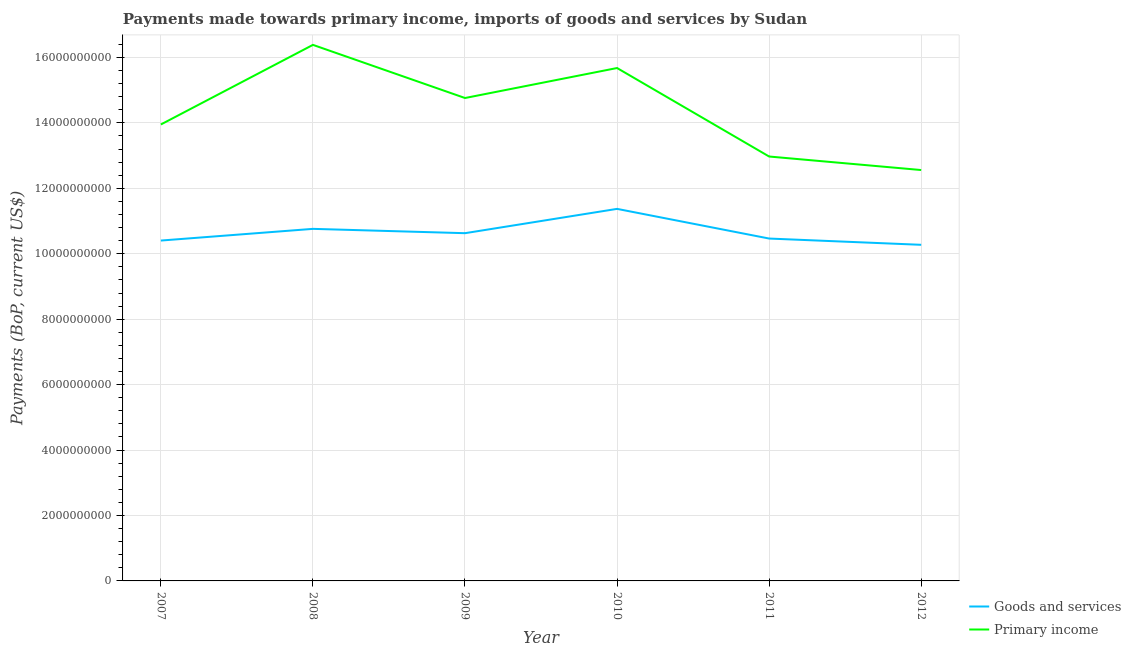How many different coloured lines are there?
Offer a very short reply. 2. Is the number of lines equal to the number of legend labels?
Offer a terse response. Yes. What is the payments made towards goods and services in 2011?
Make the answer very short. 1.05e+1. Across all years, what is the maximum payments made towards primary income?
Make the answer very short. 1.64e+1. Across all years, what is the minimum payments made towards goods and services?
Your response must be concise. 1.03e+1. In which year was the payments made towards primary income minimum?
Your answer should be compact. 2012. What is the total payments made towards primary income in the graph?
Make the answer very short. 8.63e+1. What is the difference between the payments made towards goods and services in 2009 and that in 2012?
Provide a short and direct response. 3.55e+08. What is the difference between the payments made towards primary income in 2011 and the payments made towards goods and services in 2010?
Your answer should be very brief. 1.60e+09. What is the average payments made towards primary income per year?
Your response must be concise. 1.44e+1. In the year 2012, what is the difference between the payments made towards primary income and payments made towards goods and services?
Ensure brevity in your answer.  2.29e+09. What is the ratio of the payments made towards primary income in 2008 to that in 2011?
Offer a very short reply. 1.26. Is the payments made towards primary income in 2007 less than that in 2011?
Make the answer very short. No. Is the difference between the payments made towards primary income in 2011 and 2012 greater than the difference between the payments made towards goods and services in 2011 and 2012?
Offer a terse response. Yes. What is the difference between the highest and the second highest payments made towards goods and services?
Ensure brevity in your answer.  6.11e+08. What is the difference between the highest and the lowest payments made towards goods and services?
Keep it short and to the point. 1.10e+09. In how many years, is the payments made towards goods and services greater than the average payments made towards goods and services taken over all years?
Provide a succinct answer. 2. Does the payments made towards goods and services monotonically increase over the years?
Keep it short and to the point. No. Is the payments made towards goods and services strictly greater than the payments made towards primary income over the years?
Your response must be concise. No. Is the payments made towards primary income strictly less than the payments made towards goods and services over the years?
Offer a very short reply. No. How many years are there in the graph?
Provide a short and direct response. 6. Are the values on the major ticks of Y-axis written in scientific E-notation?
Your response must be concise. No. How many legend labels are there?
Provide a short and direct response. 2. How are the legend labels stacked?
Keep it short and to the point. Vertical. What is the title of the graph?
Keep it short and to the point. Payments made towards primary income, imports of goods and services by Sudan. What is the label or title of the X-axis?
Your response must be concise. Year. What is the label or title of the Y-axis?
Offer a terse response. Payments (BoP, current US$). What is the Payments (BoP, current US$) of Goods and services in 2007?
Your answer should be compact. 1.04e+1. What is the Payments (BoP, current US$) in Primary income in 2007?
Your response must be concise. 1.40e+1. What is the Payments (BoP, current US$) in Goods and services in 2008?
Offer a terse response. 1.08e+1. What is the Payments (BoP, current US$) of Primary income in 2008?
Your answer should be very brief. 1.64e+1. What is the Payments (BoP, current US$) of Goods and services in 2009?
Your answer should be compact. 1.06e+1. What is the Payments (BoP, current US$) in Primary income in 2009?
Your response must be concise. 1.48e+1. What is the Payments (BoP, current US$) of Goods and services in 2010?
Provide a succinct answer. 1.14e+1. What is the Payments (BoP, current US$) of Primary income in 2010?
Make the answer very short. 1.57e+1. What is the Payments (BoP, current US$) in Goods and services in 2011?
Ensure brevity in your answer.  1.05e+1. What is the Payments (BoP, current US$) of Primary income in 2011?
Your response must be concise. 1.30e+1. What is the Payments (BoP, current US$) in Goods and services in 2012?
Offer a terse response. 1.03e+1. What is the Payments (BoP, current US$) in Primary income in 2012?
Offer a terse response. 1.26e+1. Across all years, what is the maximum Payments (BoP, current US$) in Goods and services?
Your response must be concise. 1.14e+1. Across all years, what is the maximum Payments (BoP, current US$) in Primary income?
Offer a terse response. 1.64e+1. Across all years, what is the minimum Payments (BoP, current US$) in Goods and services?
Your answer should be very brief. 1.03e+1. Across all years, what is the minimum Payments (BoP, current US$) in Primary income?
Your answer should be compact. 1.26e+1. What is the total Payments (BoP, current US$) in Goods and services in the graph?
Offer a very short reply. 6.39e+1. What is the total Payments (BoP, current US$) in Primary income in the graph?
Make the answer very short. 8.63e+1. What is the difference between the Payments (BoP, current US$) in Goods and services in 2007 and that in 2008?
Your answer should be very brief. -3.58e+08. What is the difference between the Payments (BoP, current US$) of Primary income in 2007 and that in 2008?
Make the answer very short. -2.43e+09. What is the difference between the Payments (BoP, current US$) of Goods and services in 2007 and that in 2009?
Keep it short and to the point. -2.25e+08. What is the difference between the Payments (BoP, current US$) of Primary income in 2007 and that in 2009?
Ensure brevity in your answer.  -8.09e+08. What is the difference between the Payments (BoP, current US$) of Goods and services in 2007 and that in 2010?
Give a very brief answer. -9.68e+08. What is the difference between the Payments (BoP, current US$) of Primary income in 2007 and that in 2010?
Ensure brevity in your answer.  -1.73e+09. What is the difference between the Payments (BoP, current US$) in Goods and services in 2007 and that in 2011?
Your answer should be very brief. -6.16e+07. What is the difference between the Payments (BoP, current US$) of Primary income in 2007 and that in 2011?
Make the answer very short. 9.79e+08. What is the difference between the Payments (BoP, current US$) of Goods and services in 2007 and that in 2012?
Make the answer very short. 1.30e+08. What is the difference between the Payments (BoP, current US$) in Primary income in 2007 and that in 2012?
Give a very brief answer. 1.39e+09. What is the difference between the Payments (BoP, current US$) in Goods and services in 2008 and that in 2009?
Give a very brief answer. 1.32e+08. What is the difference between the Payments (BoP, current US$) in Primary income in 2008 and that in 2009?
Give a very brief answer. 1.62e+09. What is the difference between the Payments (BoP, current US$) in Goods and services in 2008 and that in 2010?
Provide a succinct answer. -6.11e+08. What is the difference between the Payments (BoP, current US$) in Primary income in 2008 and that in 2010?
Your answer should be very brief. 7.08e+08. What is the difference between the Payments (BoP, current US$) in Goods and services in 2008 and that in 2011?
Your response must be concise. 2.96e+08. What is the difference between the Payments (BoP, current US$) of Primary income in 2008 and that in 2011?
Offer a terse response. 3.41e+09. What is the difference between the Payments (BoP, current US$) in Goods and services in 2008 and that in 2012?
Offer a very short reply. 4.87e+08. What is the difference between the Payments (BoP, current US$) of Primary income in 2008 and that in 2012?
Provide a succinct answer. 3.83e+09. What is the difference between the Payments (BoP, current US$) of Goods and services in 2009 and that in 2010?
Your response must be concise. -7.43e+08. What is the difference between the Payments (BoP, current US$) in Primary income in 2009 and that in 2010?
Your response must be concise. -9.17e+08. What is the difference between the Payments (BoP, current US$) of Goods and services in 2009 and that in 2011?
Keep it short and to the point. 1.64e+08. What is the difference between the Payments (BoP, current US$) in Primary income in 2009 and that in 2011?
Give a very brief answer. 1.79e+09. What is the difference between the Payments (BoP, current US$) of Goods and services in 2009 and that in 2012?
Make the answer very short. 3.55e+08. What is the difference between the Payments (BoP, current US$) of Primary income in 2009 and that in 2012?
Offer a very short reply. 2.20e+09. What is the difference between the Payments (BoP, current US$) in Goods and services in 2010 and that in 2011?
Your answer should be compact. 9.07e+08. What is the difference between the Payments (BoP, current US$) of Primary income in 2010 and that in 2011?
Ensure brevity in your answer.  2.70e+09. What is the difference between the Payments (BoP, current US$) of Goods and services in 2010 and that in 2012?
Make the answer very short. 1.10e+09. What is the difference between the Payments (BoP, current US$) of Primary income in 2010 and that in 2012?
Provide a short and direct response. 3.12e+09. What is the difference between the Payments (BoP, current US$) of Goods and services in 2011 and that in 2012?
Your answer should be compact. 1.92e+08. What is the difference between the Payments (BoP, current US$) in Primary income in 2011 and that in 2012?
Offer a very short reply. 4.13e+08. What is the difference between the Payments (BoP, current US$) in Goods and services in 2007 and the Payments (BoP, current US$) in Primary income in 2008?
Make the answer very short. -5.98e+09. What is the difference between the Payments (BoP, current US$) of Goods and services in 2007 and the Payments (BoP, current US$) of Primary income in 2009?
Keep it short and to the point. -4.36e+09. What is the difference between the Payments (BoP, current US$) of Goods and services in 2007 and the Payments (BoP, current US$) of Primary income in 2010?
Your response must be concise. -5.27e+09. What is the difference between the Payments (BoP, current US$) in Goods and services in 2007 and the Payments (BoP, current US$) in Primary income in 2011?
Your response must be concise. -2.57e+09. What is the difference between the Payments (BoP, current US$) of Goods and services in 2007 and the Payments (BoP, current US$) of Primary income in 2012?
Your answer should be compact. -2.16e+09. What is the difference between the Payments (BoP, current US$) in Goods and services in 2008 and the Payments (BoP, current US$) in Primary income in 2009?
Provide a short and direct response. -4.00e+09. What is the difference between the Payments (BoP, current US$) in Goods and services in 2008 and the Payments (BoP, current US$) in Primary income in 2010?
Provide a short and direct response. -4.92e+09. What is the difference between the Payments (BoP, current US$) of Goods and services in 2008 and the Payments (BoP, current US$) of Primary income in 2011?
Offer a terse response. -2.21e+09. What is the difference between the Payments (BoP, current US$) in Goods and services in 2008 and the Payments (BoP, current US$) in Primary income in 2012?
Your answer should be very brief. -1.80e+09. What is the difference between the Payments (BoP, current US$) in Goods and services in 2009 and the Payments (BoP, current US$) in Primary income in 2010?
Your answer should be very brief. -5.05e+09. What is the difference between the Payments (BoP, current US$) in Goods and services in 2009 and the Payments (BoP, current US$) in Primary income in 2011?
Make the answer very short. -2.34e+09. What is the difference between the Payments (BoP, current US$) in Goods and services in 2009 and the Payments (BoP, current US$) in Primary income in 2012?
Your answer should be very brief. -1.93e+09. What is the difference between the Payments (BoP, current US$) in Goods and services in 2010 and the Payments (BoP, current US$) in Primary income in 2011?
Your response must be concise. -1.60e+09. What is the difference between the Payments (BoP, current US$) of Goods and services in 2010 and the Payments (BoP, current US$) of Primary income in 2012?
Your answer should be very brief. -1.19e+09. What is the difference between the Payments (BoP, current US$) in Goods and services in 2011 and the Payments (BoP, current US$) in Primary income in 2012?
Provide a succinct answer. -2.09e+09. What is the average Payments (BoP, current US$) of Goods and services per year?
Your response must be concise. 1.07e+1. What is the average Payments (BoP, current US$) of Primary income per year?
Provide a short and direct response. 1.44e+1. In the year 2007, what is the difference between the Payments (BoP, current US$) in Goods and services and Payments (BoP, current US$) in Primary income?
Keep it short and to the point. -3.55e+09. In the year 2008, what is the difference between the Payments (BoP, current US$) in Goods and services and Payments (BoP, current US$) in Primary income?
Provide a succinct answer. -5.62e+09. In the year 2009, what is the difference between the Payments (BoP, current US$) of Goods and services and Payments (BoP, current US$) of Primary income?
Provide a succinct answer. -4.13e+09. In the year 2010, what is the difference between the Payments (BoP, current US$) in Goods and services and Payments (BoP, current US$) in Primary income?
Offer a very short reply. -4.31e+09. In the year 2011, what is the difference between the Payments (BoP, current US$) of Goods and services and Payments (BoP, current US$) of Primary income?
Provide a short and direct response. -2.51e+09. In the year 2012, what is the difference between the Payments (BoP, current US$) of Goods and services and Payments (BoP, current US$) of Primary income?
Offer a terse response. -2.29e+09. What is the ratio of the Payments (BoP, current US$) in Goods and services in 2007 to that in 2008?
Ensure brevity in your answer.  0.97. What is the ratio of the Payments (BoP, current US$) in Primary income in 2007 to that in 2008?
Provide a short and direct response. 0.85. What is the ratio of the Payments (BoP, current US$) in Goods and services in 2007 to that in 2009?
Your answer should be very brief. 0.98. What is the ratio of the Payments (BoP, current US$) in Primary income in 2007 to that in 2009?
Provide a succinct answer. 0.95. What is the ratio of the Payments (BoP, current US$) of Goods and services in 2007 to that in 2010?
Your response must be concise. 0.91. What is the ratio of the Payments (BoP, current US$) of Primary income in 2007 to that in 2010?
Provide a short and direct response. 0.89. What is the ratio of the Payments (BoP, current US$) of Goods and services in 2007 to that in 2011?
Keep it short and to the point. 0.99. What is the ratio of the Payments (BoP, current US$) of Primary income in 2007 to that in 2011?
Give a very brief answer. 1.08. What is the ratio of the Payments (BoP, current US$) of Goods and services in 2007 to that in 2012?
Offer a very short reply. 1.01. What is the ratio of the Payments (BoP, current US$) in Primary income in 2007 to that in 2012?
Give a very brief answer. 1.11. What is the ratio of the Payments (BoP, current US$) in Goods and services in 2008 to that in 2009?
Provide a succinct answer. 1.01. What is the ratio of the Payments (BoP, current US$) in Primary income in 2008 to that in 2009?
Give a very brief answer. 1.11. What is the ratio of the Payments (BoP, current US$) in Goods and services in 2008 to that in 2010?
Keep it short and to the point. 0.95. What is the ratio of the Payments (BoP, current US$) in Primary income in 2008 to that in 2010?
Make the answer very short. 1.05. What is the ratio of the Payments (BoP, current US$) of Goods and services in 2008 to that in 2011?
Ensure brevity in your answer.  1.03. What is the ratio of the Payments (BoP, current US$) in Primary income in 2008 to that in 2011?
Keep it short and to the point. 1.26. What is the ratio of the Payments (BoP, current US$) in Goods and services in 2008 to that in 2012?
Make the answer very short. 1.05. What is the ratio of the Payments (BoP, current US$) in Primary income in 2008 to that in 2012?
Provide a succinct answer. 1.3. What is the ratio of the Payments (BoP, current US$) in Goods and services in 2009 to that in 2010?
Give a very brief answer. 0.93. What is the ratio of the Payments (BoP, current US$) in Primary income in 2009 to that in 2010?
Offer a very short reply. 0.94. What is the ratio of the Payments (BoP, current US$) of Goods and services in 2009 to that in 2011?
Provide a succinct answer. 1.02. What is the ratio of the Payments (BoP, current US$) in Primary income in 2009 to that in 2011?
Your response must be concise. 1.14. What is the ratio of the Payments (BoP, current US$) in Goods and services in 2009 to that in 2012?
Offer a very short reply. 1.03. What is the ratio of the Payments (BoP, current US$) in Primary income in 2009 to that in 2012?
Give a very brief answer. 1.18. What is the ratio of the Payments (BoP, current US$) in Goods and services in 2010 to that in 2011?
Keep it short and to the point. 1.09. What is the ratio of the Payments (BoP, current US$) of Primary income in 2010 to that in 2011?
Offer a very short reply. 1.21. What is the ratio of the Payments (BoP, current US$) of Goods and services in 2010 to that in 2012?
Provide a succinct answer. 1.11. What is the ratio of the Payments (BoP, current US$) of Primary income in 2010 to that in 2012?
Provide a short and direct response. 1.25. What is the ratio of the Payments (BoP, current US$) of Goods and services in 2011 to that in 2012?
Keep it short and to the point. 1.02. What is the ratio of the Payments (BoP, current US$) in Primary income in 2011 to that in 2012?
Your response must be concise. 1.03. What is the difference between the highest and the second highest Payments (BoP, current US$) of Goods and services?
Offer a terse response. 6.11e+08. What is the difference between the highest and the second highest Payments (BoP, current US$) of Primary income?
Your response must be concise. 7.08e+08. What is the difference between the highest and the lowest Payments (BoP, current US$) of Goods and services?
Offer a terse response. 1.10e+09. What is the difference between the highest and the lowest Payments (BoP, current US$) in Primary income?
Provide a succinct answer. 3.83e+09. 